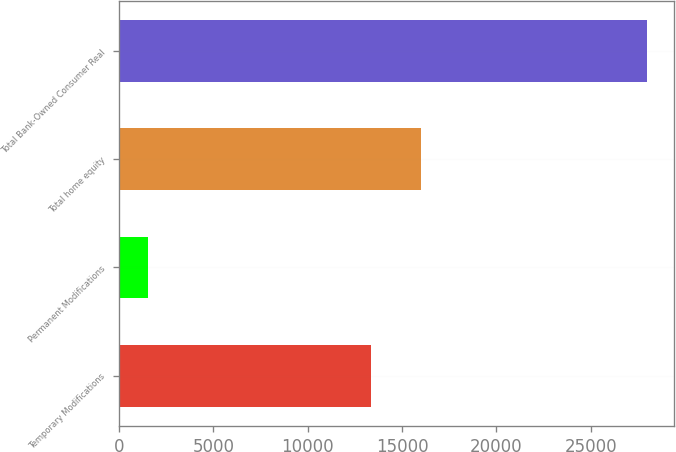Convert chart. <chart><loc_0><loc_0><loc_500><loc_500><bar_chart><fcel>Temporary Modifications<fcel>Permanent Modifications<fcel>Total home equity<fcel>Total Bank-Owned Consumer Real<nl><fcel>13352<fcel>1533<fcel>15998.2<fcel>27995<nl></chart> 